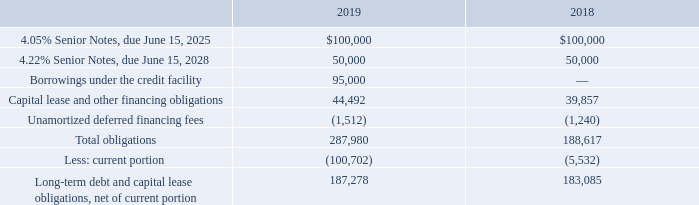4. Debt, Capital Lease Obligations and Other Financing
Debt and capital lease obligations as of September 28, 2019 and September 29, 2018, consisted of the following (in thousands):
On June 15, 2018, the Company entered into a Note Purchase Agreement (the “2018 NPA”) pursuant to which it issued an aggregate of$ 150.0 million in principal amount of unsecured senior notes, consisting of $100.0 million in principal amount of 4.05% Series A Senior Notes, due on June 15, 2025, and $50.0 million in principal amount of 4.22% Series B Senior Notes, due on June 15, 2028 (collectively, the “2018 Notes”), in a private placement. The 2018 NPA includes customary operational and financial covenants with which the Company is required to comply, including, among others, maintenance of certain financial ratios such as a total leverage ratio and a minimum interest coverage ratio. The 2018 Notes may be prepaid in whole or in part at any time, subject to payment of a makewhole amount; interest on the 2018 Notes is payable semiannually. At September 28, 2019, the Company was in compliance with the covenants under the 2018 NPA.
In connection with the issuance of the 2018 Notes, on June 15, 2018, the Company repaid, on maturity $175.0 million in principal amount of its previous 5.20% Senior Notes.
On May 15, 2019, the Company refinanced its then-existing senior unsecured revolving credit facility (the "Prior Credit Facility") by entering into a new5 -year senior unsecured revolving credit facility (collectively with the Prior Credit Facility, referred to as the "Credit Facility"), which expanded the maximum commitment from $300.0 million to $350.0 million and extended the maturity from July 5, 2021 to May 15, 2024. The maximum commitment under the Credit Facility may be further increased to $600.0 million, generally by mutual agreement of the Company and the lenders, subject to certain customary conditions. During fiscal 2019, the highest daily borrowing was $250.0 million; the average daily borrowings were $140.7 million. The Company borrowed $1,084.5 million and repaid $989.5 million of revolving borrowings under the Credit Facility during fiscal 2019. The Company was in compliance with all financial covenants relating to the Credit Agreement, which are generally consistent with those in the 2018 NPA discussed above. The Company is required to pay a commitment fee on the daily unused revolver credit commitment based on the Company's leverage ratio; the fee was 0.125% as of September 28, 2019.
Which years does the table provide information for the company's Debt and capital lease obligations? 2019, 2018. What was the amount of Capital lease and other financing obligations in 2018?
Answer scale should be: thousand. 39,857. What was the amount of total obligations in 2019?
Answer scale should be: thousand. 287,980. How many years did Capital lease and other financing obligations exceed $40,000 thousand? 2019
Answer: 1. What was the change in the Unamortized deferred financing fees between 2018 and 2019?
Answer scale should be: thousand. -1,512-(-1,240)
Answer: -272. What was the percentage change in Total obligations between 2018 and 2019?
Answer scale should be: percent. (287,980-188,617)/188,617
Answer: 52.68. 